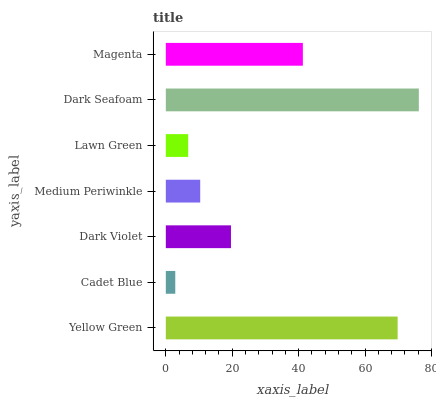Is Cadet Blue the minimum?
Answer yes or no. Yes. Is Dark Seafoam the maximum?
Answer yes or no. Yes. Is Dark Violet the minimum?
Answer yes or no. No. Is Dark Violet the maximum?
Answer yes or no. No. Is Dark Violet greater than Cadet Blue?
Answer yes or no. Yes. Is Cadet Blue less than Dark Violet?
Answer yes or no. Yes. Is Cadet Blue greater than Dark Violet?
Answer yes or no. No. Is Dark Violet less than Cadet Blue?
Answer yes or no. No. Is Dark Violet the high median?
Answer yes or no. Yes. Is Dark Violet the low median?
Answer yes or no. Yes. Is Magenta the high median?
Answer yes or no. No. Is Medium Periwinkle the low median?
Answer yes or no. No. 